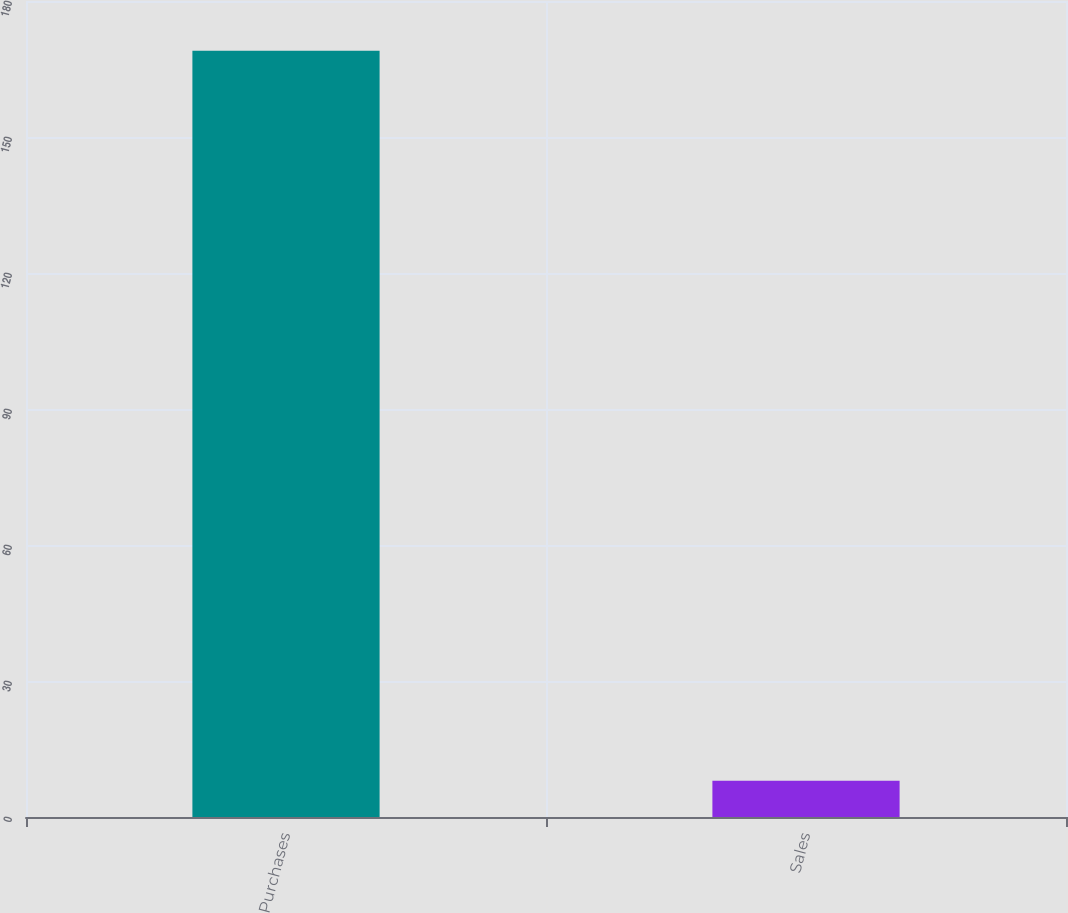Convert chart. <chart><loc_0><loc_0><loc_500><loc_500><bar_chart><fcel>Purchases<fcel>Sales<nl><fcel>169<fcel>8<nl></chart> 